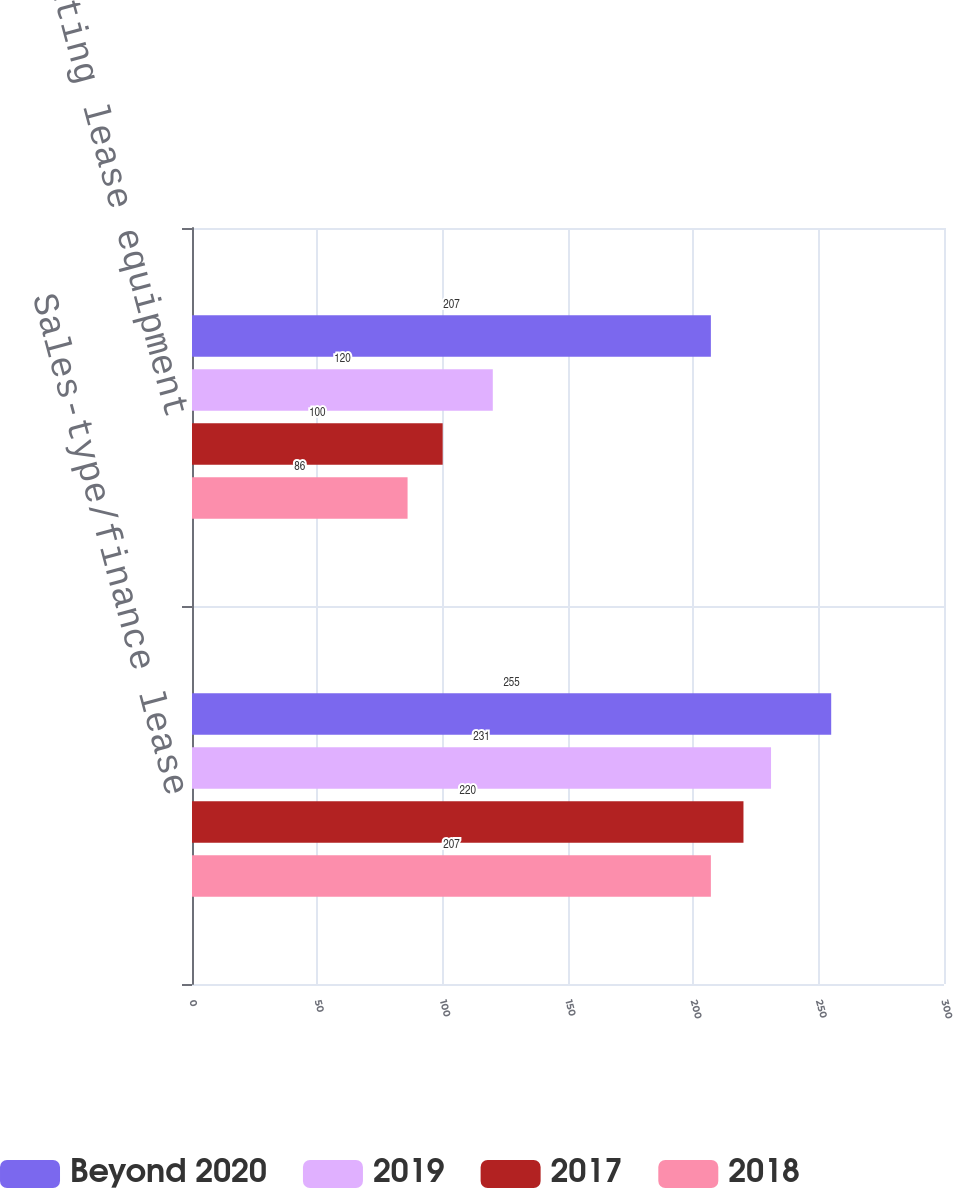Convert chart to OTSL. <chart><loc_0><loc_0><loc_500><loc_500><stacked_bar_chart><ecel><fcel>Sales-type/finance lease<fcel>Operating lease equipment<nl><fcel>Beyond 2020<fcel>255<fcel>207<nl><fcel>2019<fcel>231<fcel>120<nl><fcel>2017<fcel>220<fcel>100<nl><fcel>2018<fcel>207<fcel>86<nl></chart> 